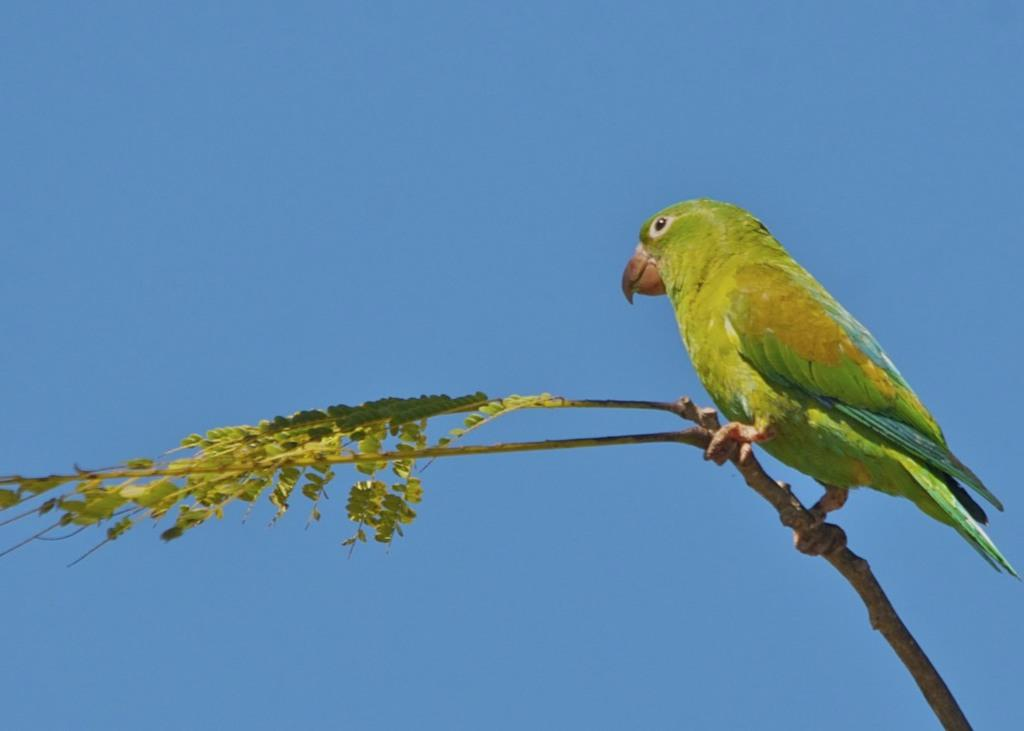What type of animal is in the image? There is a parrot in the image. Where is the parrot located? The parrot is sitting on a tree branch. What can be seen in the background of the image? The background of the image includes the blue sky. When might this image have been taken? The image was likely taken during the day, as the sky is visible and blue. What type of vegetable is the parrot holding in its beak? There is no vegetable present in the image, and the parrot is not holding anything in its beak. 